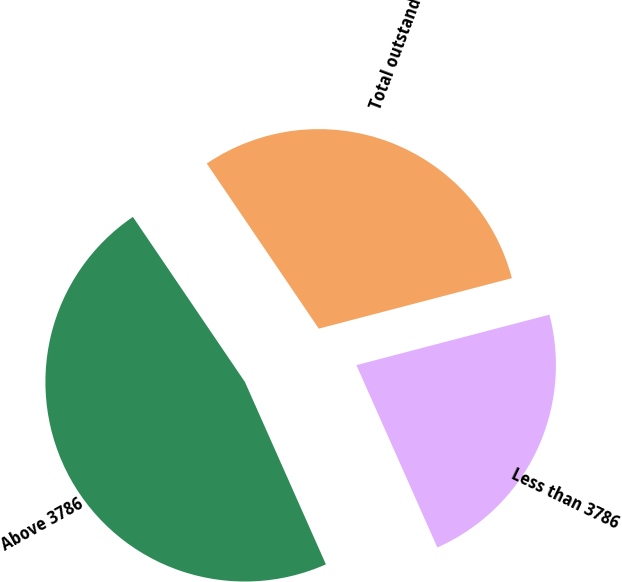Convert chart to OTSL. <chart><loc_0><loc_0><loc_500><loc_500><pie_chart><fcel>Less than 3786<fcel>Above 3786<fcel>Total outstanding<nl><fcel>22.42%<fcel>47.16%<fcel>30.42%<nl></chart> 